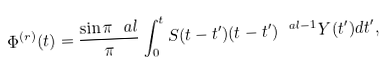Convert formula to latex. <formula><loc_0><loc_0><loc_500><loc_500>\Phi ^ { ( r ) } ( t ) = \frac { \sin \pi \ a l } { \pi } \int _ { 0 } ^ { t } S ( t - t ^ { \prime } ) ( t - t ^ { \prime } ) ^ { \ a l - 1 } Y ( t ^ { \prime } ) d t ^ { \prime } ,</formula> 